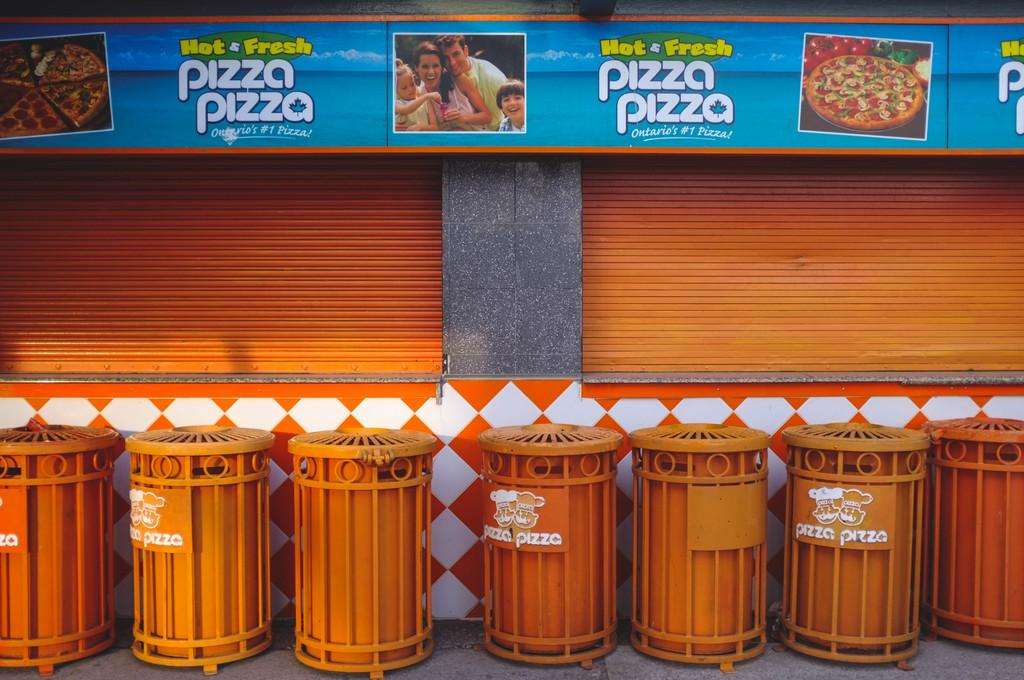<image>
Relay a brief, clear account of the picture shown. Orange bins under a sign which says "pizza pizza". 